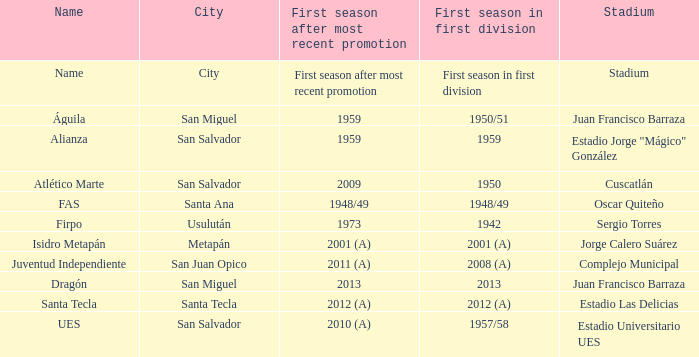When was Alianza's first season in first division with a promotion after 1959? 1959.0. 